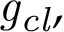Convert formula to latex. <formula><loc_0><loc_0><loc_500><loc_500>{ g _ { c l } } ,</formula> 